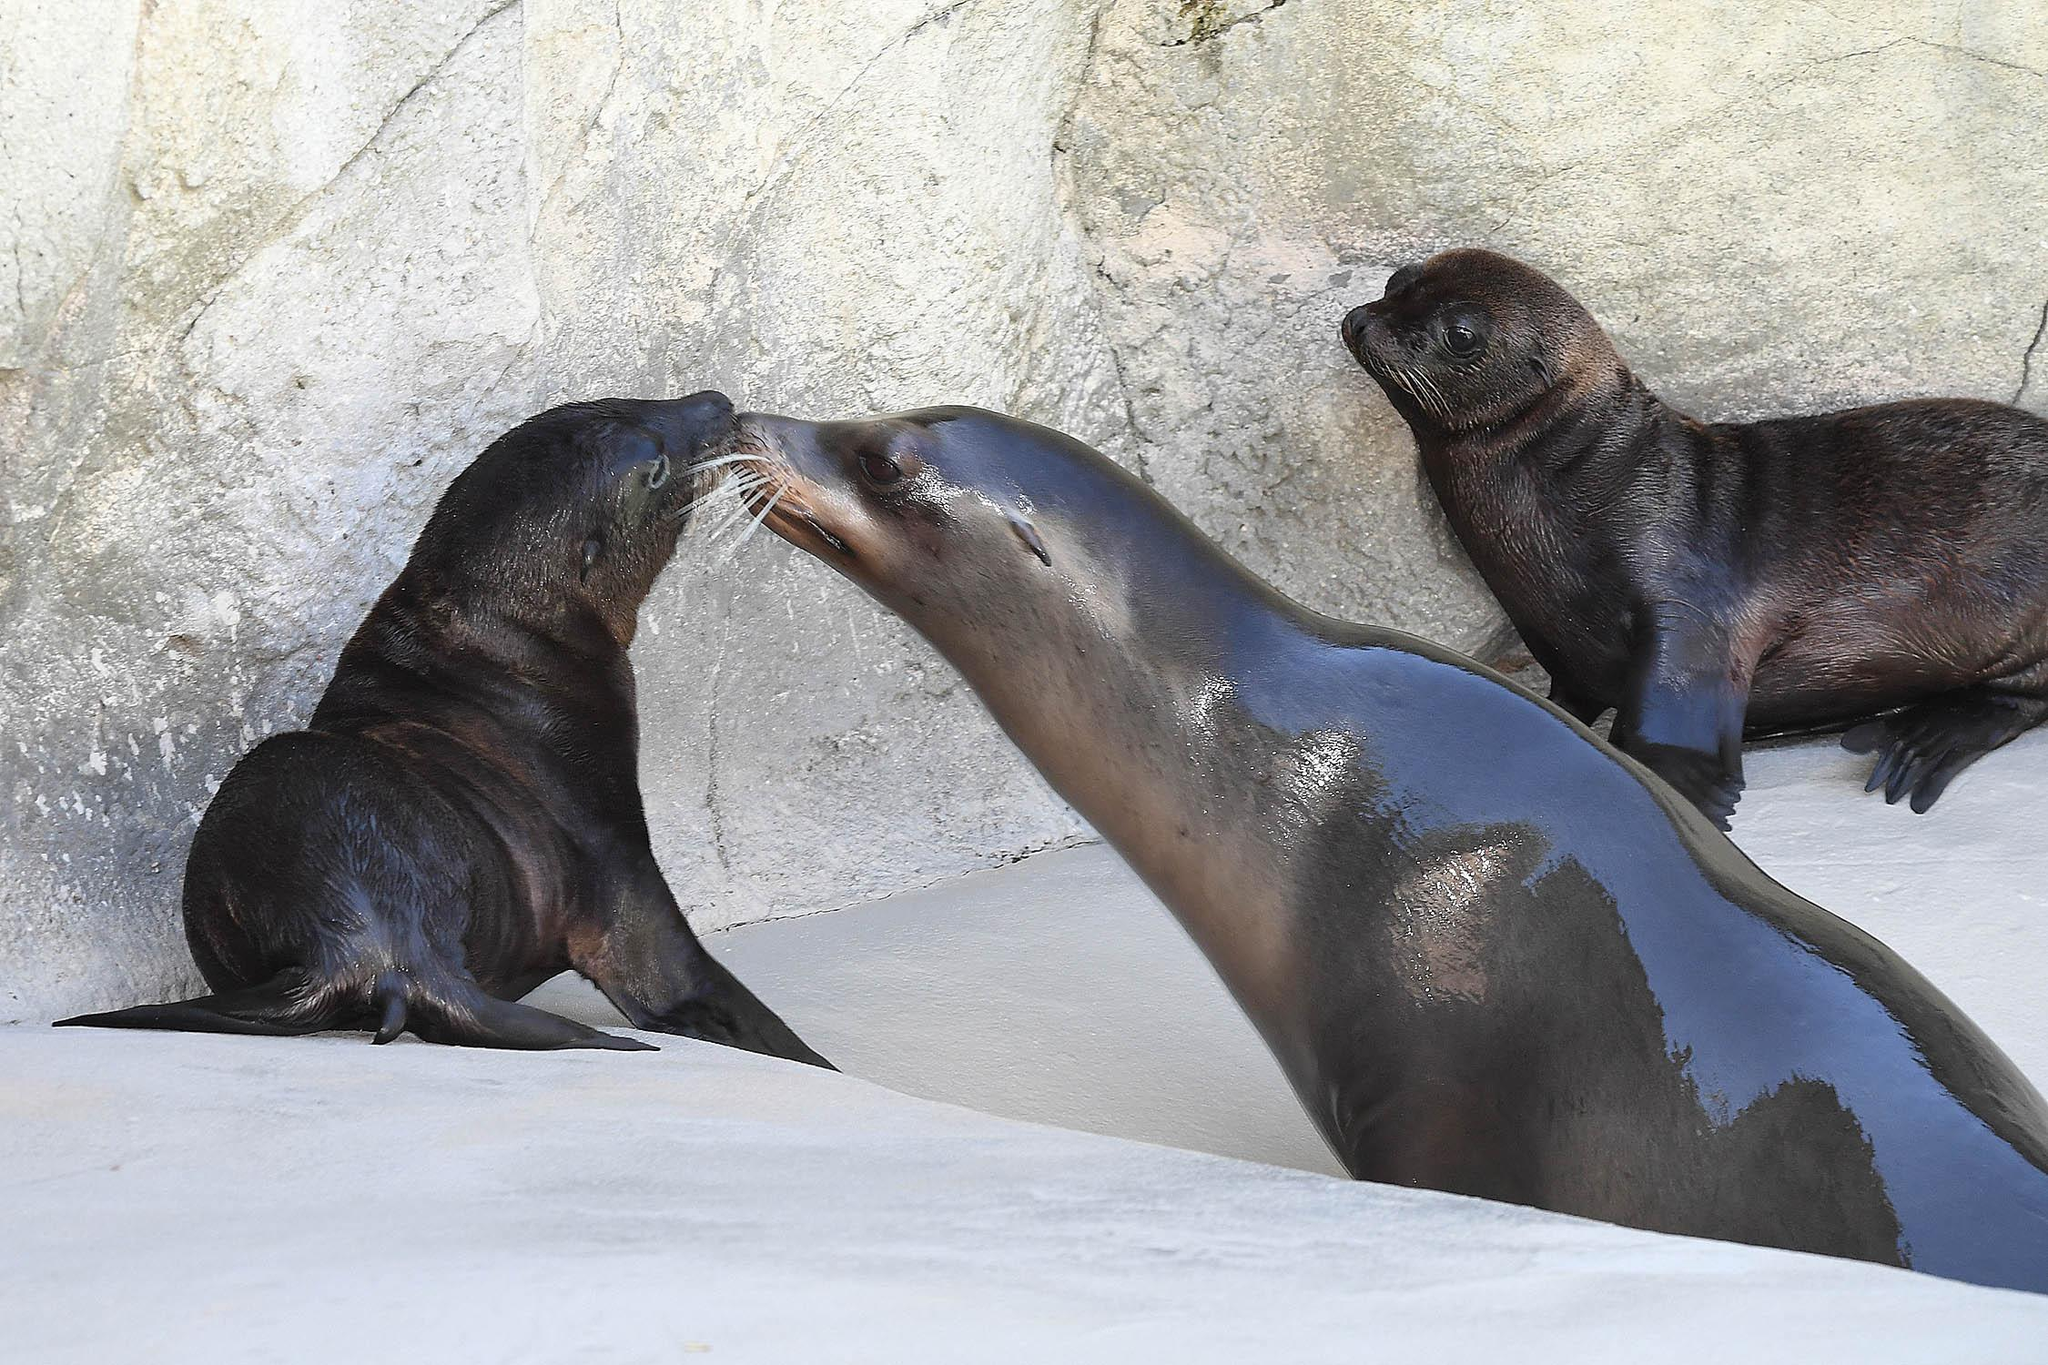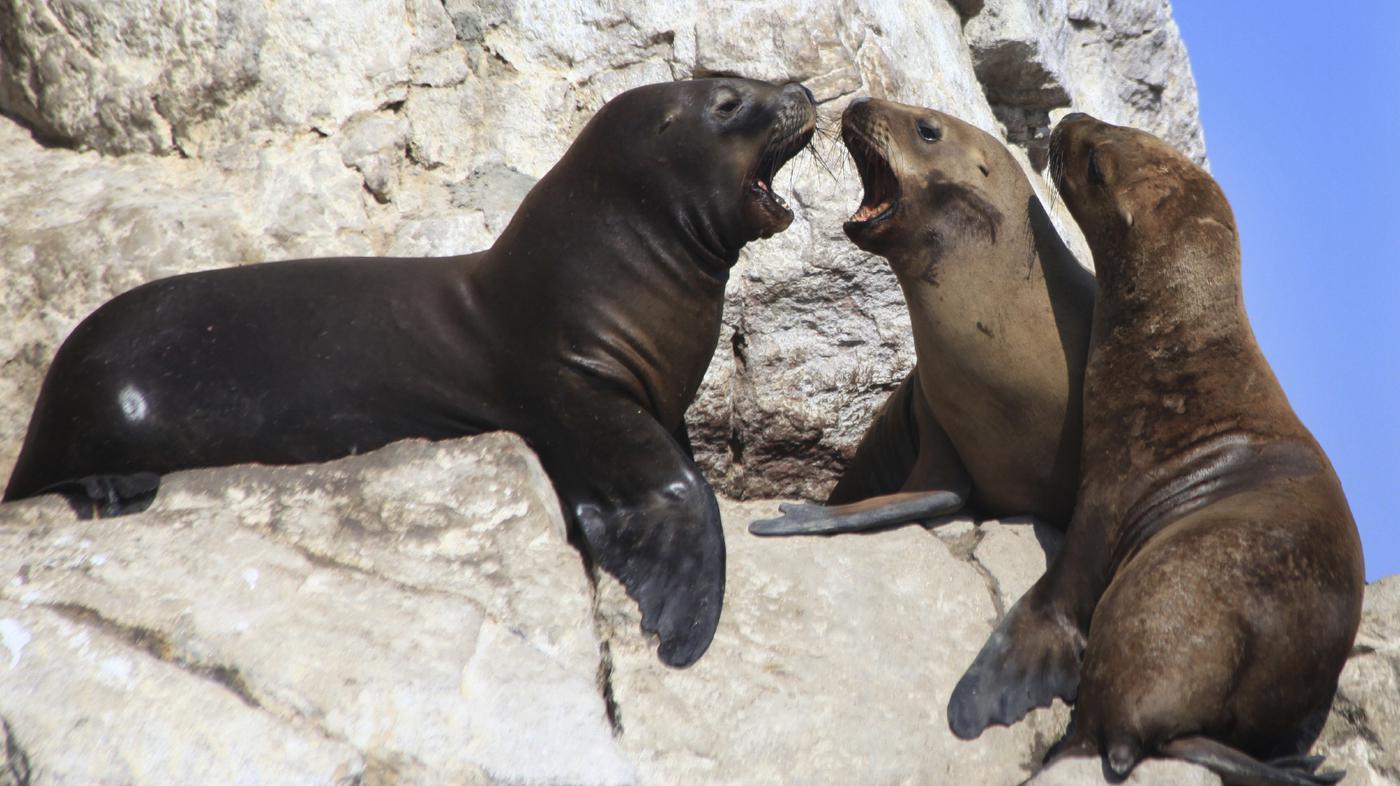The first image is the image on the left, the second image is the image on the right. For the images shown, is this caption "The left and right images have the same amount of seals visible." true? Answer yes or no. Yes. The first image is the image on the left, the second image is the image on the right. Assess this claim about the two images: "An adult seal to the right of a baby seal extends its neck to touch noses with the smaller animal.". Correct or not? Answer yes or no. Yes. 